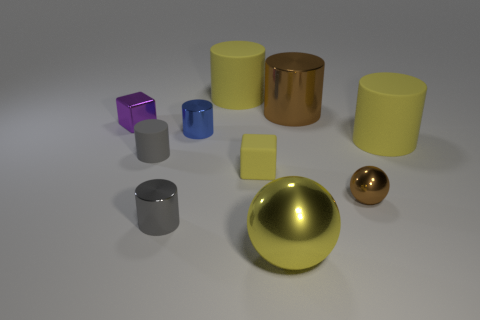There is a large yellow object that is both to the left of the small brown shiny thing and behind the tiny brown shiny object; what shape is it?
Ensure brevity in your answer.  Cylinder. There is a brown ball; does it have the same size as the yellow ball that is in front of the tiny gray metal thing?
Your response must be concise. No. There is a small rubber object that is the same shape as the large brown object; what color is it?
Provide a short and direct response. Gray. Does the gray thing to the left of the gray shiny object have the same size as the shiny cylinder that is in front of the brown sphere?
Provide a short and direct response. Yes. Is the gray metallic thing the same shape as the big yellow metallic object?
Give a very brief answer. No. What number of objects are cubes that are behind the tiny matte cylinder or rubber cylinders?
Your answer should be compact. 4. Is there a big yellow thing of the same shape as the blue metal thing?
Your response must be concise. Yes. Is the number of brown shiny balls that are in front of the large metal ball the same as the number of small gray cubes?
Make the answer very short. Yes. There is a object that is the same color as the tiny metallic sphere; what is its shape?
Provide a short and direct response. Cylinder. What number of blocks are the same size as the gray shiny cylinder?
Give a very brief answer. 2. 